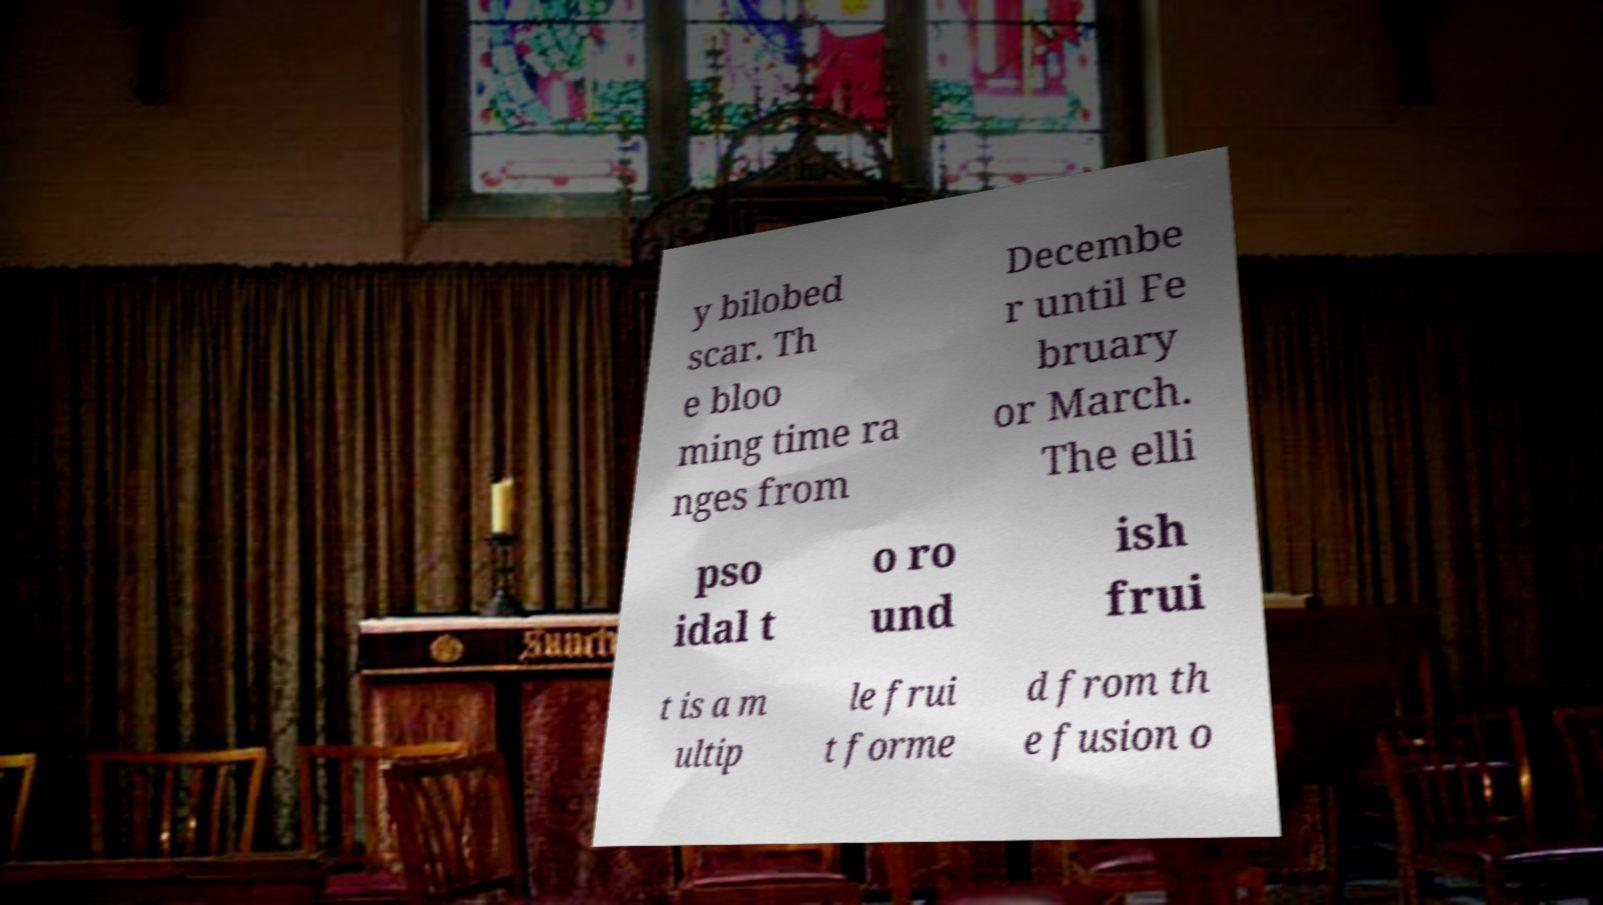Please identify and transcribe the text found in this image. y bilobed scar. Th e bloo ming time ra nges from Decembe r until Fe bruary or March. The elli pso idal t o ro und ish frui t is a m ultip le frui t forme d from th e fusion o 